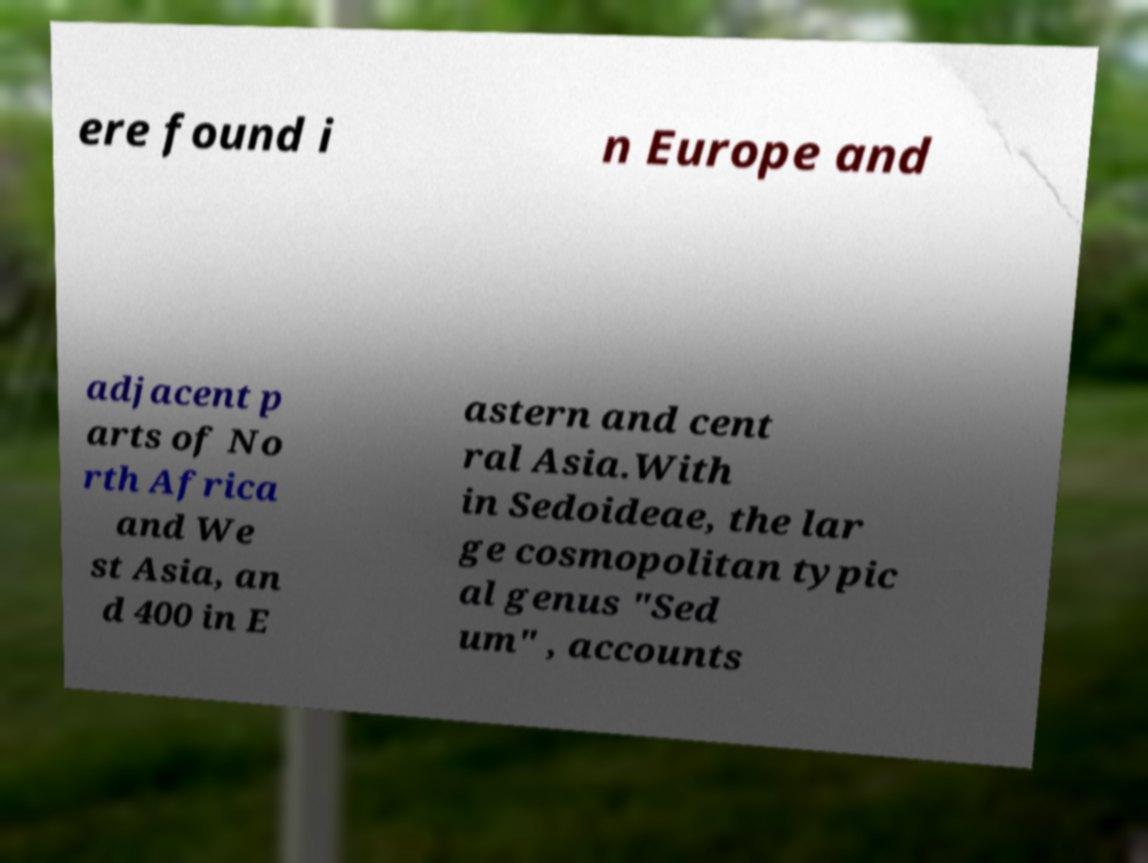Please read and relay the text visible in this image. What does it say? ere found i n Europe and adjacent p arts of No rth Africa and We st Asia, an d 400 in E astern and cent ral Asia.With in Sedoideae, the lar ge cosmopolitan typic al genus "Sed um" , accounts 